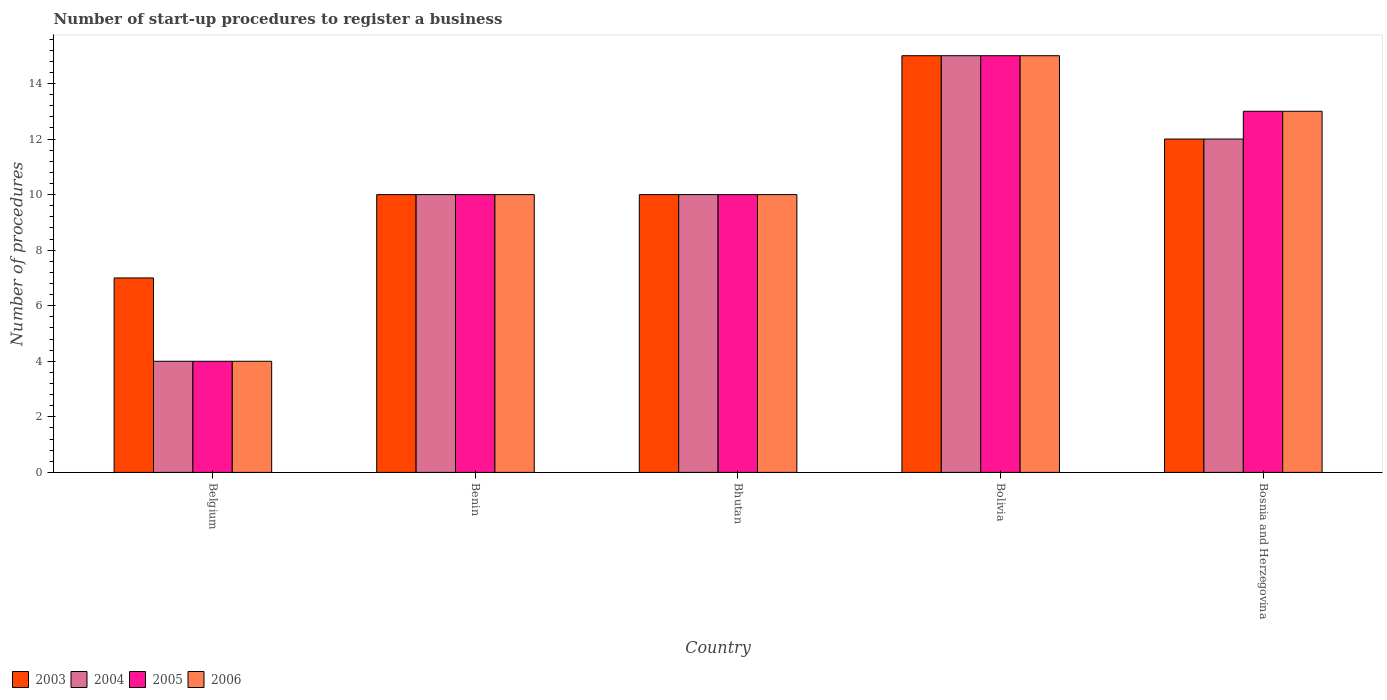How many different coloured bars are there?
Ensure brevity in your answer.  4. How many groups of bars are there?
Your response must be concise. 5. Are the number of bars per tick equal to the number of legend labels?
Your answer should be very brief. Yes. How many bars are there on the 1st tick from the left?
Your answer should be compact. 4. How many bars are there on the 5th tick from the right?
Ensure brevity in your answer.  4. What is the label of the 3rd group of bars from the left?
Make the answer very short. Bhutan. Across all countries, what is the minimum number of procedures required to register a business in 2004?
Give a very brief answer. 4. In which country was the number of procedures required to register a business in 2004 minimum?
Ensure brevity in your answer.  Belgium. What is the difference between the number of procedures required to register a business in 2004 in Benin and that in Bosnia and Herzegovina?
Offer a very short reply. -2. What is the difference between the number of procedures required to register a business in 2003 in Bhutan and the number of procedures required to register a business in 2006 in Bosnia and Herzegovina?
Your answer should be compact. -3. What is the difference between the number of procedures required to register a business of/in 2004 and number of procedures required to register a business of/in 2005 in Bhutan?
Give a very brief answer. 0. Is the number of procedures required to register a business in 2006 in Belgium less than that in Bolivia?
Provide a short and direct response. Yes. Is the difference between the number of procedures required to register a business in 2004 in Belgium and Bosnia and Herzegovina greater than the difference between the number of procedures required to register a business in 2005 in Belgium and Bosnia and Herzegovina?
Your answer should be very brief. Yes. What is the difference between the highest and the second highest number of procedures required to register a business in 2004?
Offer a very short reply. -2. What is the difference between the highest and the lowest number of procedures required to register a business in 2004?
Keep it short and to the point. 11. Is the sum of the number of procedures required to register a business in 2003 in Belgium and Bolivia greater than the maximum number of procedures required to register a business in 2005 across all countries?
Your response must be concise. Yes. Is it the case that in every country, the sum of the number of procedures required to register a business in 2004 and number of procedures required to register a business in 2006 is greater than the sum of number of procedures required to register a business in 2003 and number of procedures required to register a business in 2005?
Give a very brief answer. No. What does the 3rd bar from the left in Bhutan represents?
Provide a succinct answer. 2005. Is it the case that in every country, the sum of the number of procedures required to register a business in 2006 and number of procedures required to register a business in 2003 is greater than the number of procedures required to register a business in 2004?
Ensure brevity in your answer.  Yes. How many countries are there in the graph?
Provide a succinct answer. 5. What is the difference between two consecutive major ticks on the Y-axis?
Offer a terse response. 2. Are the values on the major ticks of Y-axis written in scientific E-notation?
Give a very brief answer. No. Where does the legend appear in the graph?
Your response must be concise. Bottom left. How many legend labels are there?
Keep it short and to the point. 4. What is the title of the graph?
Your answer should be compact. Number of start-up procedures to register a business. Does "1996" appear as one of the legend labels in the graph?
Provide a short and direct response. No. What is the label or title of the X-axis?
Keep it short and to the point. Country. What is the label or title of the Y-axis?
Make the answer very short. Number of procedures. What is the Number of procedures of 2005 in Belgium?
Your answer should be compact. 4. What is the Number of procedures of 2003 in Benin?
Your response must be concise. 10. What is the Number of procedures of 2006 in Benin?
Your answer should be very brief. 10. What is the Number of procedures in 2003 in Bhutan?
Make the answer very short. 10. What is the Number of procedures in 2006 in Bhutan?
Your response must be concise. 10. What is the Number of procedures of 2003 in Bolivia?
Keep it short and to the point. 15. What is the Number of procedures in 2004 in Bolivia?
Ensure brevity in your answer.  15. What is the Number of procedures in 2006 in Bolivia?
Offer a very short reply. 15. What is the Number of procedures of 2003 in Bosnia and Herzegovina?
Your answer should be very brief. 12. What is the Number of procedures of 2005 in Bosnia and Herzegovina?
Provide a short and direct response. 13. Across all countries, what is the maximum Number of procedures of 2004?
Keep it short and to the point. 15. Across all countries, what is the maximum Number of procedures in 2005?
Your answer should be compact. 15. Across all countries, what is the maximum Number of procedures in 2006?
Keep it short and to the point. 15. Across all countries, what is the minimum Number of procedures of 2004?
Keep it short and to the point. 4. Across all countries, what is the minimum Number of procedures in 2005?
Keep it short and to the point. 4. What is the total Number of procedures of 2003 in the graph?
Ensure brevity in your answer.  54. What is the total Number of procedures in 2004 in the graph?
Provide a short and direct response. 51. What is the difference between the Number of procedures in 2004 in Belgium and that in Benin?
Provide a short and direct response. -6. What is the difference between the Number of procedures in 2005 in Belgium and that in Benin?
Offer a very short reply. -6. What is the difference between the Number of procedures of 2006 in Belgium and that in Benin?
Keep it short and to the point. -6. What is the difference between the Number of procedures of 2003 in Belgium and that in Bhutan?
Give a very brief answer. -3. What is the difference between the Number of procedures in 2005 in Belgium and that in Bhutan?
Your response must be concise. -6. What is the difference between the Number of procedures of 2005 in Belgium and that in Bolivia?
Your answer should be compact. -11. What is the difference between the Number of procedures in 2006 in Belgium and that in Bosnia and Herzegovina?
Make the answer very short. -9. What is the difference between the Number of procedures in 2003 in Benin and that in Bhutan?
Your answer should be compact. 0. What is the difference between the Number of procedures in 2004 in Benin and that in Bhutan?
Ensure brevity in your answer.  0. What is the difference between the Number of procedures of 2003 in Benin and that in Bolivia?
Provide a short and direct response. -5. What is the difference between the Number of procedures in 2004 in Benin and that in Bolivia?
Give a very brief answer. -5. What is the difference between the Number of procedures of 2005 in Benin and that in Bolivia?
Your response must be concise. -5. What is the difference between the Number of procedures in 2003 in Bhutan and that in Bosnia and Herzegovina?
Ensure brevity in your answer.  -2. What is the difference between the Number of procedures of 2004 in Bhutan and that in Bosnia and Herzegovina?
Offer a terse response. -2. What is the difference between the Number of procedures of 2003 in Bolivia and that in Bosnia and Herzegovina?
Your answer should be very brief. 3. What is the difference between the Number of procedures in 2004 in Bolivia and that in Bosnia and Herzegovina?
Keep it short and to the point. 3. What is the difference between the Number of procedures in 2005 in Bolivia and that in Bosnia and Herzegovina?
Give a very brief answer. 2. What is the difference between the Number of procedures in 2003 in Belgium and the Number of procedures in 2004 in Benin?
Offer a very short reply. -3. What is the difference between the Number of procedures of 2003 in Belgium and the Number of procedures of 2006 in Benin?
Your response must be concise. -3. What is the difference between the Number of procedures in 2004 in Belgium and the Number of procedures in 2005 in Benin?
Provide a short and direct response. -6. What is the difference between the Number of procedures in 2003 in Belgium and the Number of procedures in 2004 in Bhutan?
Offer a terse response. -3. What is the difference between the Number of procedures in 2003 in Belgium and the Number of procedures in 2005 in Bhutan?
Your answer should be very brief. -3. What is the difference between the Number of procedures of 2004 in Belgium and the Number of procedures of 2006 in Bhutan?
Offer a terse response. -6. What is the difference between the Number of procedures of 2003 in Belgium and the Number of procedures of 2004 in Bolivia?
Give a very brief answer. -8. What is the difference between the Number of procedures of 2003 in Belgium and the Number of procedures of 2006 in Bolivia?
Your answer should be compact. -8. What is the difference between the Number of procedures in 2003 in Belgium and the Number of procedures in 2004 in Bosnia and Herzegovina?
Give a very brief answer. -5. What is the difference between the Number of procedures in 2004 in Belgium and the Number of procedures in 2005 in Bosnia and Herzegovina?
Ensure brevity in your answer.  -9. What is the difference between the Number of procedures in 2004 in Belgium and the Number of procedures in 2006 in Bosnia and Herzegovina?
Your answer should be compact. -9. What is the difference between the Number of procedures of 2003 in Benin and the Number of procedures of 2004 in Bhutan?
Provide a succinct answer. 0. What is the difference between the Number of procedures in 2003 in Benin and the Number of procedures in 2005 in Bhutan?
Keep it short and to the point. 0. What is the difference between the Number of procedures of 2003 in Benin and the Number of procedures of 2006 in Bhutan?
Give a very brief answer. 0. What is the difference between the Number of procedures in 2004 in Benin and the Number of procedures in 2006 in Bhutan?
Your response must be concise. 0. What is the difference between the Number of procedures of 2005 in Benin and the Number of procedures of 2006 in Bhutan?
Your response must be concise. 0. What is the difference between the Number of procedures in 2003 in Benin and the Number of procedures in 2004 in Bolivia?
Your answer should be compact. -5. What is the difference between the Number of procedures of 2003 in Benin and the Number of procedures of 2006 in Bolivia?
Your response must be concise. -5. What is the difference between the Number of procedures in 2004 in Benin and the Number of procedures in 2005 in Bolivia?
Offer a terse response. -5. What is the difference between the Number of procedures of 2003 in Benin and the Number of procedures of 2004 in Bosnia and Herzegovina?
Provide a succinct answer. -2. What is the difference between the Number of procedures in 2003 in Benin and the Number of procedures in 2005 in Bosnia and Herzegovina?
Provide a succinct answer. -3. What is the difference between the Number of procedures of 2004 in Benin and the Number of procedures of 2006 in Bosnia and Herzegovina?
Keep it short and to the point. -3. What is the difference between the Number of procedures in 2003 in Bhutan and the Number of procedures in 2004 in Bolivia?
Provide a short and direct response. -5. What is the difference between the Number of procedures in 2004 in Bhutan and the Number of procedures in 2005 in Bolivia?
Keep it short and to the point. -5. What is the difference between the Number of procedures in 2004 in Bhutan and the Number of procedures in 2006 in Bolivia?
Offer a very short reply. -5. What is the difference between the Number of procedures of 2005 in Bhutan and the Number of procedures of 2006 in Bolivia?
Keep it short and to the point. -5. What is the difference between the Number of procedures in 2003 in Bhutan and the Number of procedures in 2004 in Bosnia and Herzegovina?
Offer a terse response. -2. What is the difference between the Number of procedures of 2003 in Bhutan and the Number of procedures of 2005 in Bosnia and Herzegovina?
Offer a very short reply. -3. What is the difference between the Number of procedures of 2003 in Bhutan and the Number of procedures of 2006 in Bosnia and Herzegovina?
Offer a very short reply. -3. What is the difference between the Number of procedures of 2004 in Bhutan and the Number of procedures of 2006 in Bosnia and Herzegovina?
Provide a succinct answer. -3. What is the difference between the Number of procedures in 2003 in Bolivia and the Number of procedures in 2004 in Bosnia and Herzegovina?
Your answer should be very brief. 3. What is the difference between the Number of procedures of 2004 in Bolivia and the Number of procedures of 2005 in Bosnia and Herzegovina?
Your answer should be very brief. 2. What is the difference between the Number of procedures of 2004 in Bolivia and the Number of procedures of 2006 in Bosnia and Herzegovina?
Provide a succinct answer. 2. What is the average Number of procedures of 2003 per country?
Your answer should be very brief. 10.8. What is the average Number of procedures in 2004 per country?
Offer a very short reply. 10.2. What is the average Number of procedures of 2006 per country?
Your answer should be very brief. 10.4. What is the difference between the Number of procedures in 2003 and Number of procedures in 2005 in Belgium?
Keep it short and to the point. 3. What is the difference between the Number of procedures of 2004 and Number of procedures of 2005 in Belgium?
Give a very brief answer. 0. What is the difference between the Number of procedures in 2005 and Number of procedures in 2006 in Belgium?
Your response must be concise. 0. What is the difference between the Number of procedures in 2003 and Number of procedures in 2005 in Benin?
Your answer should be compact. 0. What is the difference between the Number of procedures of 2003 and Number of procedures of 2006 in Benin?
Keep it short and to the point. 0. What is the difference between the Number of procedures of 2005 and Number of procedures of 2006 in Benin?
Provide a short and direct response. 0. What is the difference between the Number of procedures of 2003 and Number of procedures of 2004 in Bhutan?
Your answer should be very brief. 0. What is the difference between the Number of procedures of 2003 and Number of procedures of 2004 in Bolivia?
Provide a succinct answer. 0. What is the difference between the Number of procedures of 2003 and Number of procedures of 2005 in Bolivia?
Your response must be concise. 0. What is the difference between the Number of procedures in 2003 and Number of procedures in 2006 in Bolivia?
Make the answer very short. 0. What is the difference between the Number of procedures of 2005 and Number of procedures of 2006 in Bolivia?
Give a very brief answer. 0. What is the difference between the Number of procedures in 2005 and Number of procedures in 2006 in Bosnia and Herzegovina?
Your answer should be compact. 0. What is the ratio of the Number of procedures of 2004 in Belgium to that in Benin?
Provide a succinct answer. 0.4. What is the ratio of the Number of procedures in 2006 in Belgium to that in Benin?
Make the answer very short. 0.4. What is the ratio of the Number of procedures in 2003 in Belgium to that in Bhutan?
Offer a very short reply. 0.7. What is the ratio of the Number of procedures of 2004 in Belgium to that in Bhutan?
Ensure brevity in your answer.  0.4. What is the ratio of the Number of procedures of 2003 in Belgium to that in Bolivia?
Your response must be concise. 0.47. What is the ratio of the Number of procedures in 2004 in Belgium to that in Bolivia?
Make the answer very short. 0.27. What is the ratio of the Number of procedures in 2005 in Belgium to that in Bolivia?
Your answer should be compact. 0.27. What is the ratio of the Number of procedures of 2006 in Belgium to that in Bolivia?
Provide a short and direct response. 0.27. What is the ratio of the Number of procedures of 2003 in Belgium to that in Bosnia and Herzegovina?
Your answer should be compact. 0.58. What is the ratio of the Number of procedures in 2004 in Belgium to that in Bosnia and Herzegovina?
Your answer should be very brief. 0.33. What is the ratio of the Number of procedures of 2005 in Belgium to that in Bosnia and Herzegovina?
Provide a succinct answer. 0.31. What is the ratio of the Number of procedures of 2006 in Belgium to that in Bosnia and Herzegovina?
Your response must be concise. 0.31. What is the ratio of the Number of procedures in 2003 in Benin to that in Bolivia?
Keep it short and to the point. 0.67. What is the ratio of the Number of procedures in 2004 in Benin to that in Bolivia?
Provide a succinct answer. 0.67. What is the ratio of the Number of procedures of 2005 in Benin to that in Bolivia?
Keep it short and to the point. 0.67. What is the ratio of the Number of procedures of 2006 in Benin to that in Bolivia?
Your response must be concise. 0.67. What is the ratio of the Number of procedures of 2004 in Benin to that in Bosnia and Herzegovina?
Keep it short and to the point. 0.83. What is the ratio of the Number of procedures of 2005 in Benin to that in Bosnia and Herzegovina?
Offer a very short reply. 0.77. What is the ratio of the Number of procedures of 2006 in Benin to that in Bosnia and Herzegovina?
Offer a very short reply. 0.77. What is the ratio of the Number of procedures in 2003 in Bhutan to that in Bolivia?
Keep it short and to the point. 0.67. What is the ratio of the Number of procedures in 2006 in Bhutan to that in Bolivia?
Your answer should be very brief. 0.67. What is the ratio of the Number of procedures in 2003 in Bhutan to that in Bosnia and Herzegovina?
Provide a short and direct response. 0.83. What is the ratio of the Number of procedures in 2004 in Bhutan to that in Bosnia and Herzegovina?
Give a very brief answer. 0.83. What is the ratio of the Number of procedures in 2005 in Bhutan to that in Bosnia and Herzegovina?
Your answer should be compact. 0.77. What is the ratio of the Number of procedures of 2006 in Bhutan to that in Bosnia and Herzegovina?
Your answer should be compact. 0.77. What is the ratio of the Number of procedures of 2004 in Bolivia to that in Bosnia and Herzegovina?
Provide a short and direct response. 1.25. What is the ratio of the Number of procedures of 2005 in Bolivia to that in Bosnia and Herzegovina?
Ensure brevity in your answer.  1.15. What is the ratio of the Number of procedures of 2006 in Bolivia to that in Bosnia and Herzegovina?
Offer a terse response. 1.15. What is the difference between the highest and the second highest Number of procedures in 2003?
Make the answer very short. 3. What is the difference between the highest and the lowest Number of procedures in 2003?
Make the answer very short. 8. What is the difference between the highest and the lowest Number of procedures of 2005?
Provide a short and direct response. 11. What is the difference between the highest and the lowest Number of procedures of 2006?
Your answer should be compact. 11. 